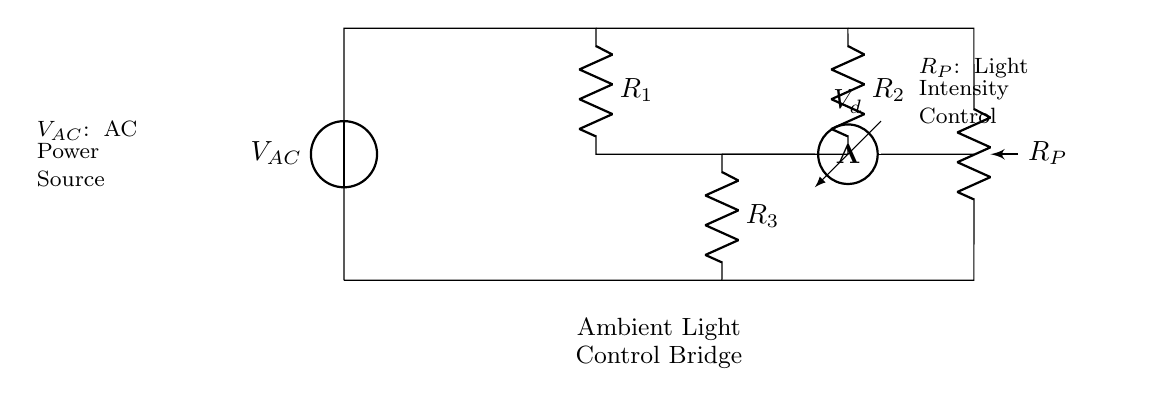What is the type of voltage source used? The circuit employs an alternating current (AC) voltage source, indicated by the symbol V_AC at the top left of the diagram.
Answer: AC What does the potentiometer control? The potentiometer labeled R_P is used to control the intensity of the ambient light in the meditation room, as suggested by its labeling in the diagram.
Answer: Light intensity How many resistors are present in the circuit? There are three resistors in the circuit, labeled as R_1, R_2, and R_3, each connected in varying configurations around the bridge.
Answer: Three What is the purpose of the voltmeter? The voltmeter is used to measure the voltage drop, V_d, across specific points in the circuit, specifically between R_2 and R_P, providing a reading of the voltage within the bridge.
Answer: Measure voltage What role do the resistors play in the bridge circuit? The resistors R_1, R_2, and R_3 create a balance in the AC bridge, allowing for precise control of the voltage which influences the light intensity, by adjusting the relation of their resistances.
Answer: Provide control How is the circuit designed to control ambient lighting? The circuit is designed to control ambient lighting through the potentiometer, which changes resistance and thereby alters the current flowing through the light source, adjusting the light levels accordingly.
Answer: Through potentiometer adjustment What is the component connected to the AC source at the top left? The component connected to the AC source is the resistor R_1, which is part of the bridge configuration that helps in balancing the circuit for light control.
Answer: Resistor R_1 